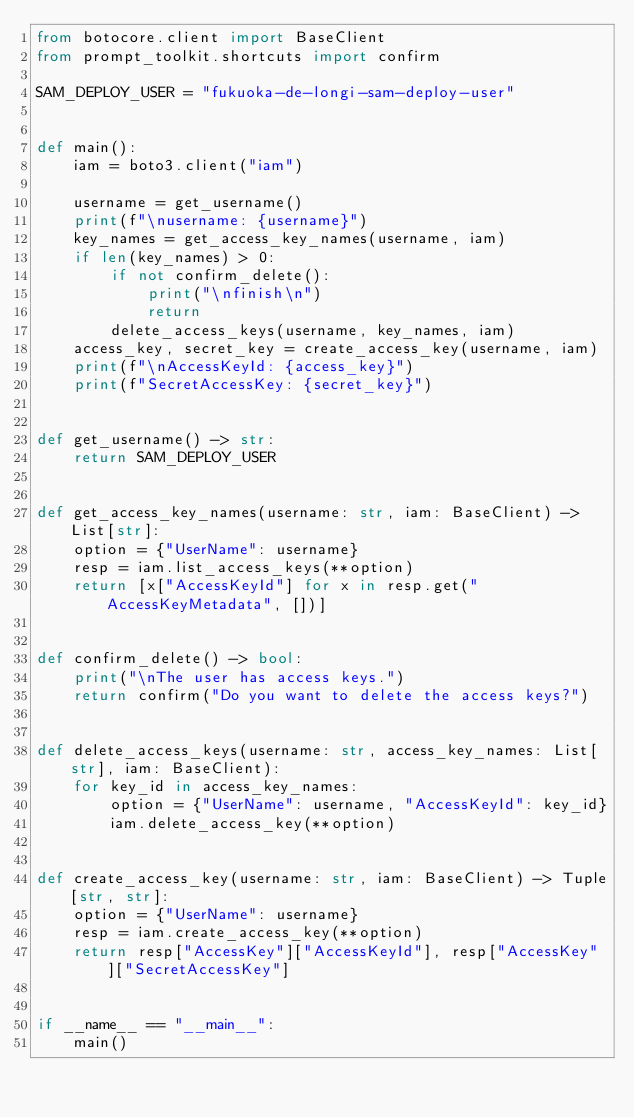Convert code to text. <code><loc_0><loc_0><loc_500><loc_500><_Python_>from botocore.client import BaseClient
from prompt_toolkit.shortcuts import confirm

SAM_DEPLOY_USER = "fukuoka-de-longi-sam-deploy-user"


def main():
    iam = boto3.client("iam")

    username = get_username()
    print(f"\nusername: {username}")
    key_names = get_access_key_names(username, iam)
    if len(key_names) > 0:
        if not confirm_delete():
            print("\nfinish\n")
            return
        delete_access_keys(username, key_names, iam)
    access_key, secret_key = create_access_key(username, iam)
    print(f"\nAccessKeyId: {access_key}")
    print(f"SecretAccessKey: {secret_key}")


def get_username() -> str:
    return SAM_DEPLOY_USER


def get_access_key_names(username: str, iam: BaseClient) -> List[str]:
    option = {"UserName": username}
    resp = iam.list_access_keys(**option)
    return [x["AccessKeyId"] for x in resp.get("AccessKeyMetadata", [])]


def confirm_delete() -> bool:
    print("\nThe user has access keys.")
    return confirm("Do you want to delete the access keys?")


def delete_access_keys(username: str, access_key_names: List[str], iam: BaseClient):
    for key_id in access_key_names:
        option = {"UserName": username, "AccessKeyId": key_id}
        iam.delete_access_key(**option)


def create_access_key(username: str, iam: BaseClient) -> Tuple[str, str]:
    option = {"UserName": username}
    resp = iam.create_access_key(**option)
    return resp["AccessKey"]["AccessKeyId"], resp["AccessKey"]["SecretAccessKey"]


if __name__ == "__main__":
    main()
</code> 